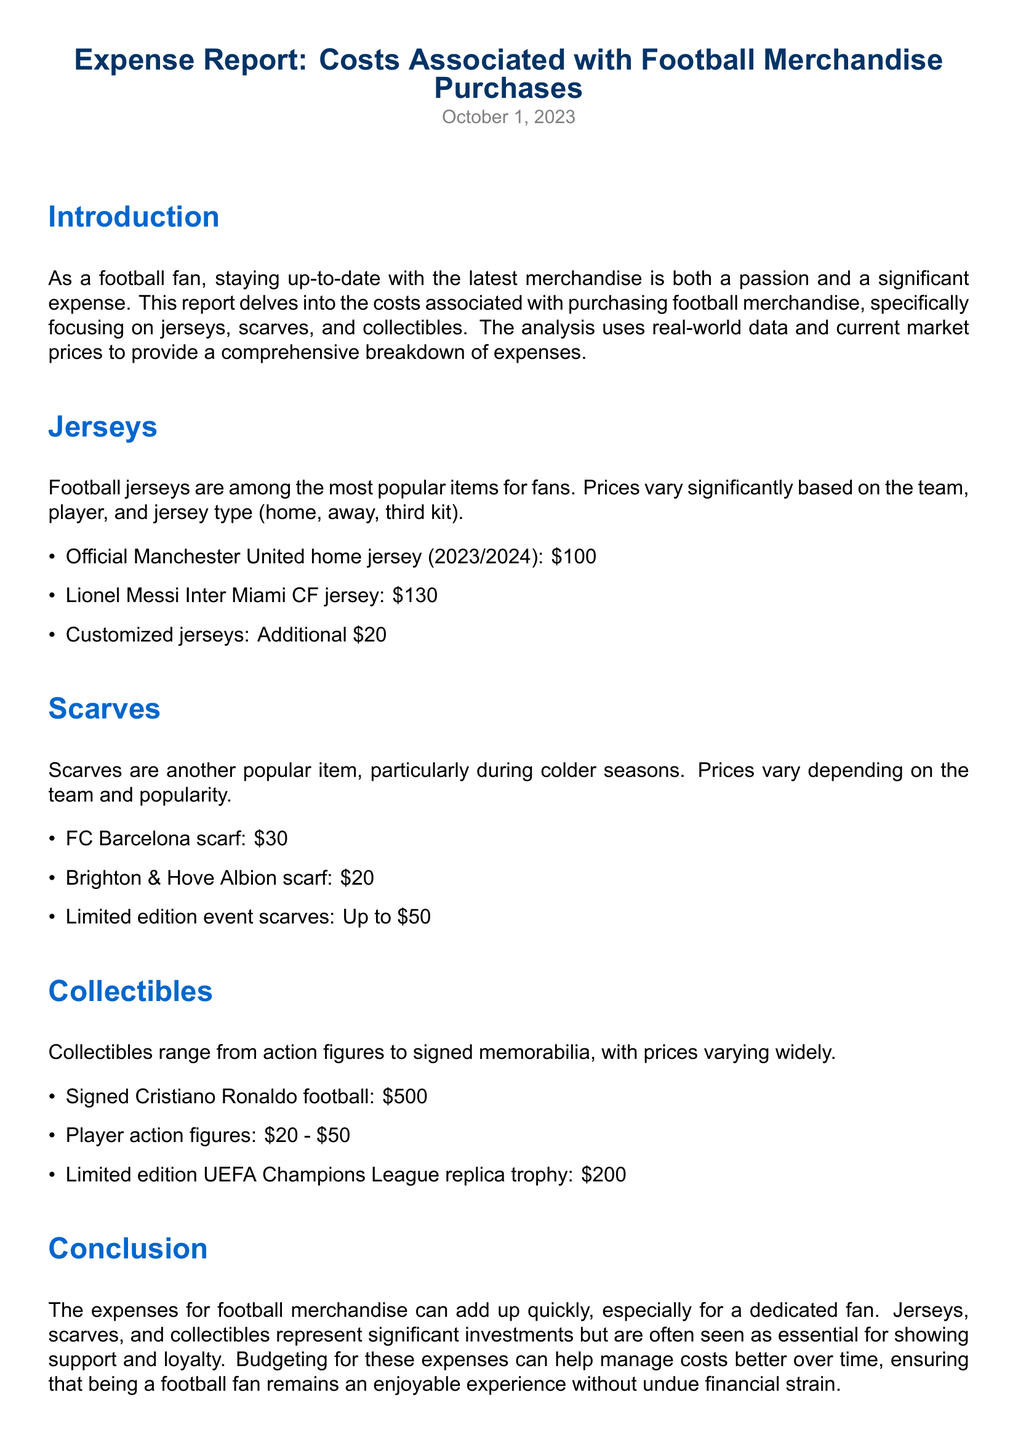what is the price of an official Manchester United home jersey? The price of the official Manchester United home jersey (2023/2024) is listed in the jerseys section of the document.
Answer: $100 what is the cost range for player action figures? The cost range for player action figures is mentioned in the collectibles section of the document.
Answer: $20 - $50 how much does a limited edition UEFA Champions League replica trophy cost? The cost of the limited edition UEFA Champions League replica trophy is found in the collectibles section.
Answer: $200 what is the price of a customized jersey? The additional cost for a customized jersey is provided in the jerseys section.
Answer: Additional $20 which scarf has the lowest price? The scarf with the lowest price can be identified in the scarves section of the document.
Answer: $20 how much are limited edition event scarves priced at? The pricing for limited edition event scarves is specified in the scarves section.
Answer: Up to $50 which football player's signed memorabilia is listed with the highest price? The signed memorabilia prices can be compared in the collectibles section to determine the highest price.
Answer: Cristiano Ronaldo what is the total estimated expense for purchasing one jersey, one scarf, and one collectible? The total estimated expense can be calculated using the samples from the jerseys, scarves, and collectibles sections.
Answer: $330 